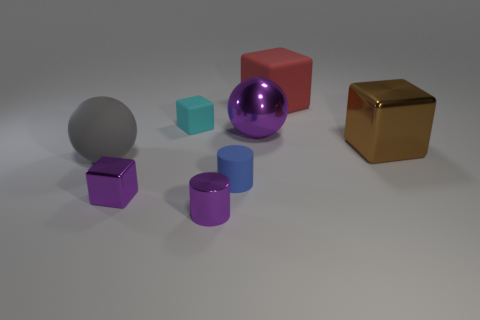What could be the context or purpose of this collection of objects? This assortment of objects could represent a 3D modeling test, showcasing different geometric shapes, colors, and materials to demonstrate rendering capabilities in a virtual environment. Is there an object that seems out of place in this setting? Not particularly, all objects are consistent with the theme of a rendering test. However, the sphere and cylinder differ from the other objects, which are all variations of cubes, possibly providing a study in contrast. 